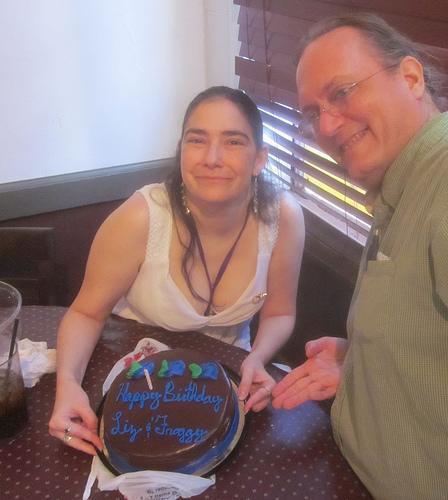How many people are shown?
Give a very brief answer. 2. 